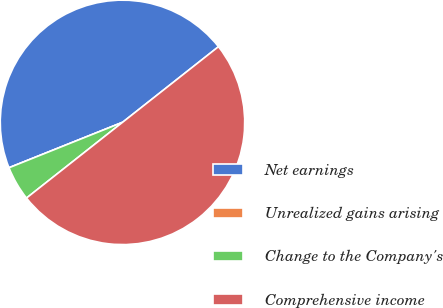<chart> <loc_0><loc_0><loc_500><loc_500><pie_chart><fcel>Net earnings<fcel>Unrealized gains arising<fcel>Change to the Company's<fcel>Comprehensive income<nl><fcel>45.43%<fcel>0.0%<fcel>4.57%<fcel>50.0%<nl></chart> 